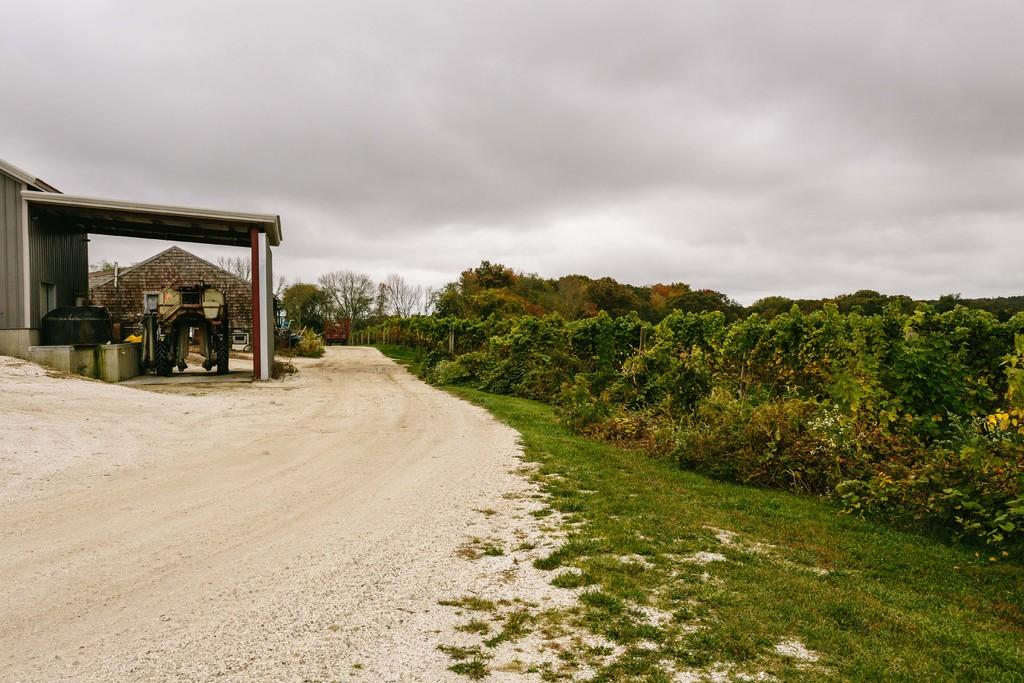What structure is located on the left side of the image? There is a building on the left side of the image. What type of vegetation can be seen in the image? There are plants, trees, and grass visible in the image. What type of pathway is present in the image? There is a road in the image. What is the condition of the sky in the image? The sky is cloudy in the image. Can you tell me how many balls are being juggled by the partner in the image? There is no partner or ball present in the image. What type of wish can be granted by the trees in the image? There are no wishes or magical elements associated with the trees in the image; they are simply trees. 